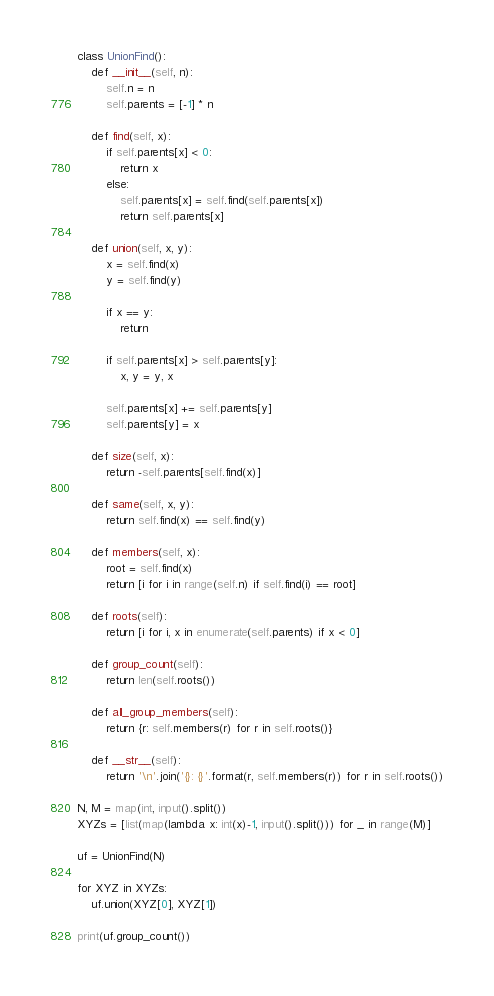<code> <loc_0><loc_0><loc_500><loc_500><_Python_>class UnionFind():
    def __init__(self, n):
        self.n = n
        self.parents = [-1] * n

    def find(self, x):
        if self.parents[x] < 0:
            return x
        else:
            self.parents[x] = self.find(self.parents[x])
            return self.parents[x]

    def union(self, x, y):
        x = self.find(x)
        y = self.find(y)

        if x == y:
            return

        if self.parents[x] > self.parents[y]:
            x, y = y, x

        self.parents[x] += self.parents[y]
        self.parents[y] = x

    def size(self, x):
        return -self.parents[self.find(x)]

    def same(self, x, y):
        return self.find(x) == self.find(y)

    def members(self, x):
        root = self.find(x)
        return [i for i in range(self.n) if self.find(i) == root]

    def roots(self):
        return [i for i, x in enumerate(self.parents) if x < 0]

    def group_count(self):
        return len(self.roots())

    def all_group_members(self):
        return {r: self.members(r) for r in self.roots()}

    def __str__(self):
        return '\n'.join('{}: {}'.format(r, self.members(r)) for r in self.roots())
      
N, M = map(int, input().split())
XYZs = [list(map(lambda x: int(x)-1, input().split())) for _ in range(M)]

uf = UnionFind(N)

for XYZ in XYZs:
    uf.union(XYZ[0], XYZ[1])

print(uf.group_count())</code> 